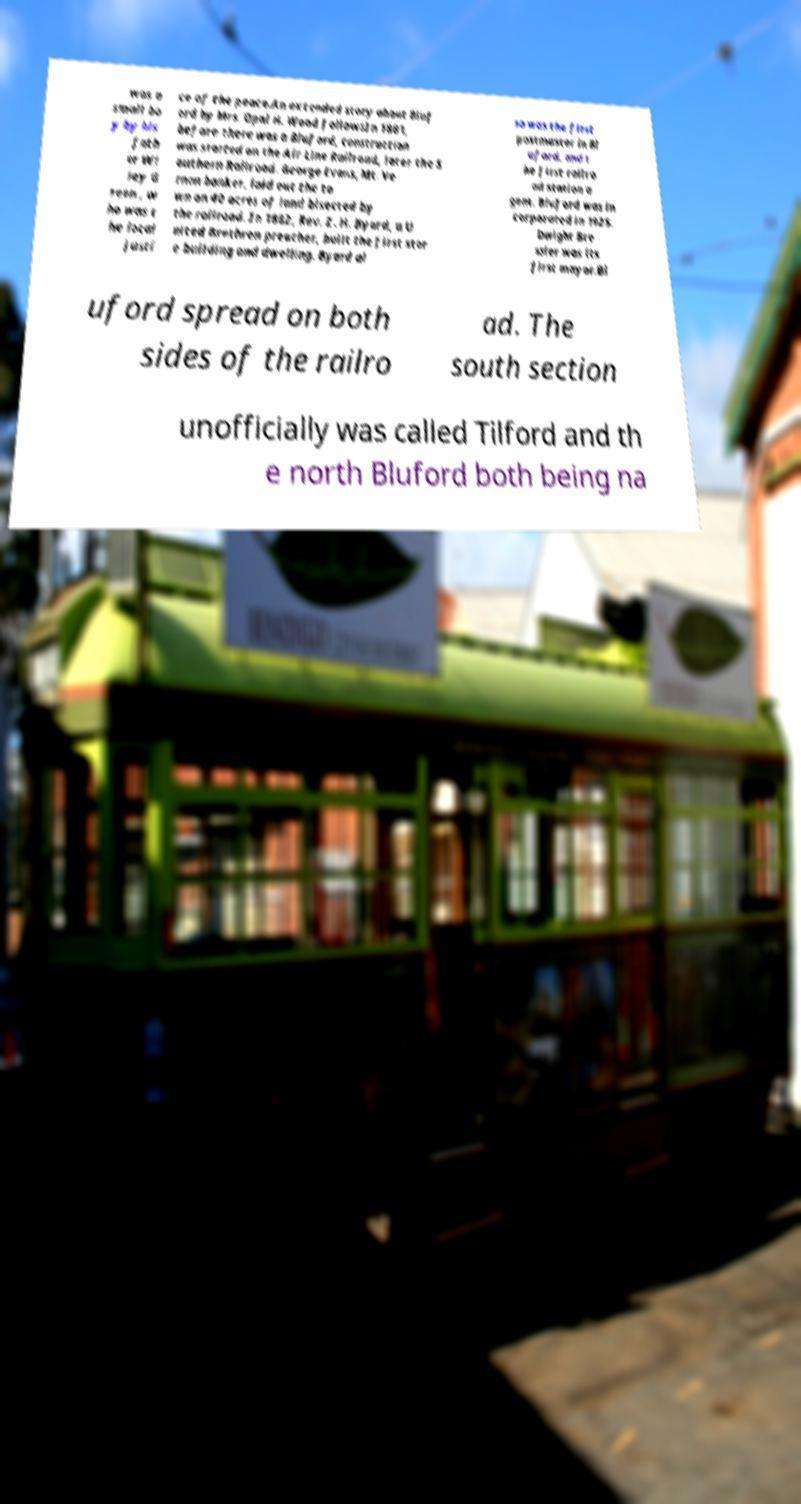There's text embedded in this image that I need extracted. Can you transcribe it verbatim? was a small bo y by his fath er Wi ley G reen , w ho was t he local justi ce of the peace.An extended story about Bluf ord by Mrs. Opal H. Wood followsIn 1881, before there was a Bluford, construction was started on the Air Line Railroad, later the S outhern Railroad. George Evans, Mt. Ve rnon banker, laid out the to wn on 40 acres of land bisected by the railroad. In 1882, Rev. Z. H. Byard, a U nited Brethren preacher, built the first stor e building and dwelling. Byard al so was the first postmaster in Bl uford, and t he first railro ad station a gent. Bluford was in corporated in 1925. Dwight Bre ssler was its first mayor.Bl uford spread on both sides of the railro ad. The south section unofficially was called Tilford and th e north Bluford both being na 